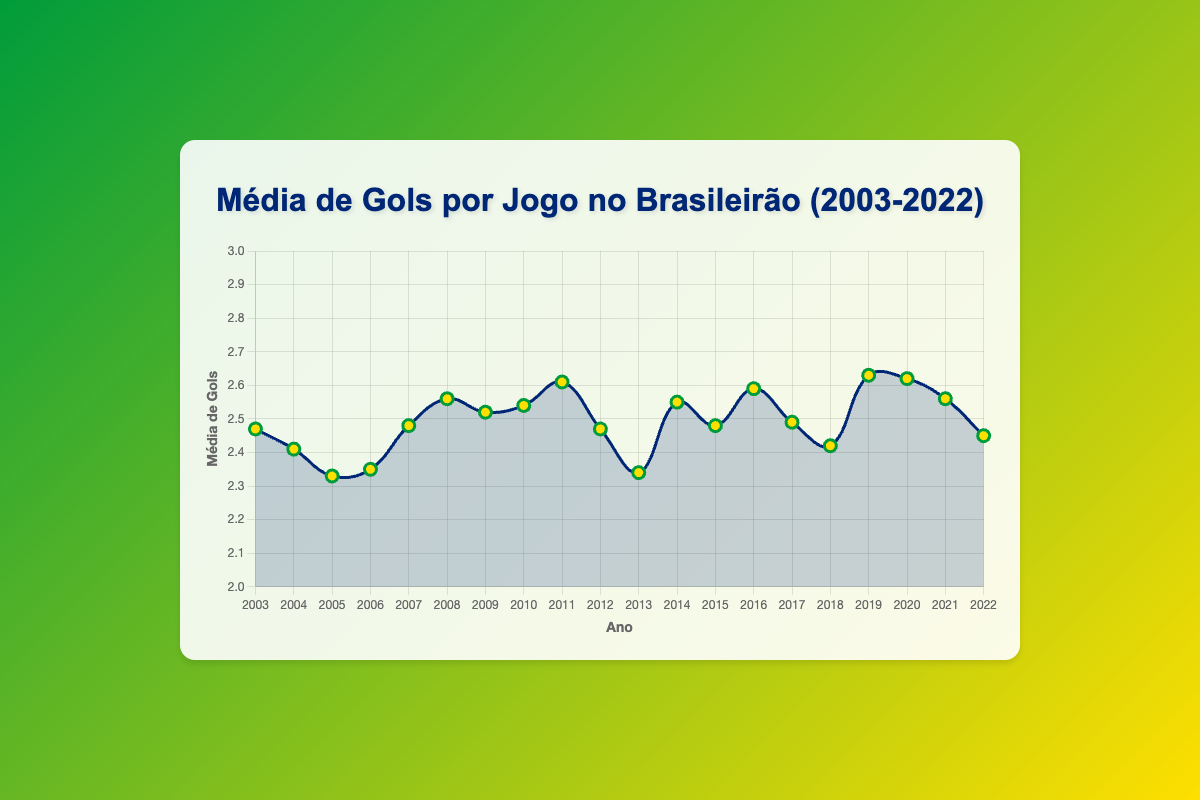What year had the highest average goals per game? By looking at the highest point in the graph, we see that 2019 had the highest average goals per game at 2.63.
Answer: 2019 What is the difference in average goals between 2010 and 2013? The average goals in 2010 were 2.54, and in 2013 it was 2.34. Subtracting these gives 2.54 - 2.34 = 0.20.
Answer: 0.20 In which year was the average goals per game the lowest? The lowest point in the graph is in 2005, with an average of 2.33 goals per game.
Answer: 2005 What was the average goals per game in 2010 and how does it compare with 2009? In 2010, the average goals per game were 2.54, while in 2009 it was 2.52. Comparing these, 2010 had a slightly higher average goals per game by 0.02.
Answer: 2010 had 0.02 more than 2009 Over the span of 20 years, how many years had an average goals per game greater than 2.50? The years with an average greater than 2.50 are 2008 (2.56), 2009 (2.52), 2010 (2.54), 2011 (2.61), 2014 (2.55), 2016 (2.59), 2019 (2.63), 2020 (2.62), and 2021 (2.56). Counting these gives us 9 years.
Answer: 9 years What is the median average goals per game from 2003 to 2022? To find the median, we need to order the values: [2.33, 2.34, 2.34 (2013), 2.35, 2.41, 2.42, 2.45, 2.47 (2012), 2.47 (2003), 2.48 (2015), 2.48 (2007), 2.49, 2.52, 2.54, 2.55, 2.56 (2021), 2.56 (2008), 2.59, 2.61, 2.62, 2.63]. The median value is the 10th value in this sorted list, which is 2.48.
Answer: 2.48 Which year showed the most significant increase in average goals per game compared to the previous year? By examining the differences year by year, the most significant increase is from 2004 (2.41) to 2005 (2.33), which is a rise of 0.08 goals.
Answer: 2008 to 2009 Is there a general trend in average goals per game over the 20 years? By visual inspection of the line plot, we can see fluctuations in the average goals per game, but there is no clear upward or downward trend.
Answer: No clear trend How does the average goals per game in 2022 compare with the average in 2003? The average goals in 2003 were 2.47, and in 2022, they were 2.45. Comparing both, 2022 had 0.02 fewer average goals per game than 2003.
Answer: 2.45, 0.02 fewer 